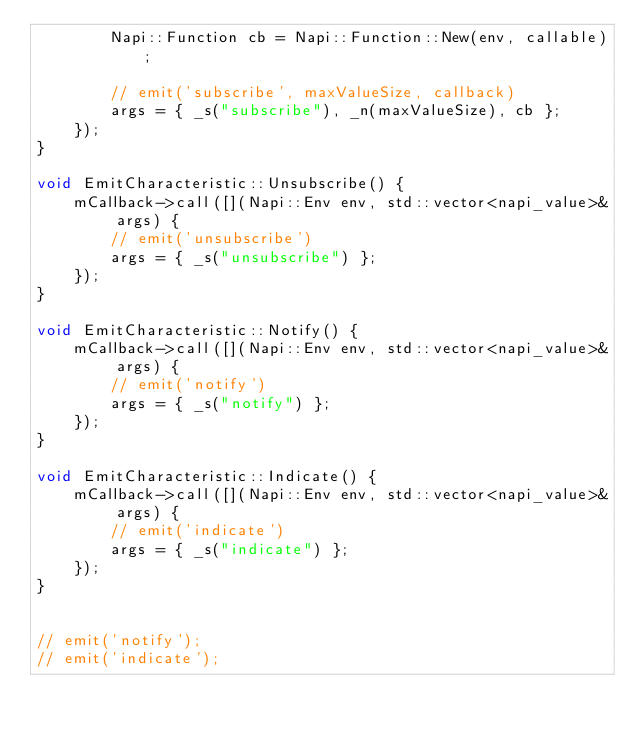Convert code to text. <code><loc_0><loc_0><loc_500><loc_500><_ObjectiveC_>        Napi::Function cb = Napi::Function::New(env, callable);

        // emit('subscribe', maxValueSize, callback)
        args = { _s("subscribe"), _n(maxValueSize), cb };
    });
}

void EmitCharacteristic::Unsubscribe() {
    mCallback->call([](Napi::Env env, std::vector<napi_value>& args) {
        // emit('unsubscribe')
        args = { _s("unsubscribe") };
    });
}

void EmitCharacteristic::Notify() {
    mCallback->call([](Napi::Env env, std::vector<napi_value>& args) {
        // emit('notify')
        args = { _s("notify") };
    });
}

void EmitCharacteristic::Indicate() {
    mCallback->call([](Napi::Env env, std::vector<napi_value>& args) {
        // emit('indicate')
        args = { _s("indicate") };
    });
}


// emit('notify');
// emit('indicate');
</code> 